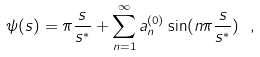<formula> <loc_0><loc_0><loc_500><loc_500>\psi ( s ) = \pi \frac { s } { s ^ { \ast } } + \sum _ { n = 1 } ^ { \infty } a ^ { ( 0 ) } _ { n } \sin ( n \pi \frac { s } { s ^ { \ast } } ) \ ,</formula> 